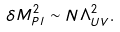<formula> <loc_0><loc_0><loc_500><loc_500>\delta M _ { P l } ^ { 2 } \sim N \Lambda _ { U V } ^ { 2 } .</formula> 